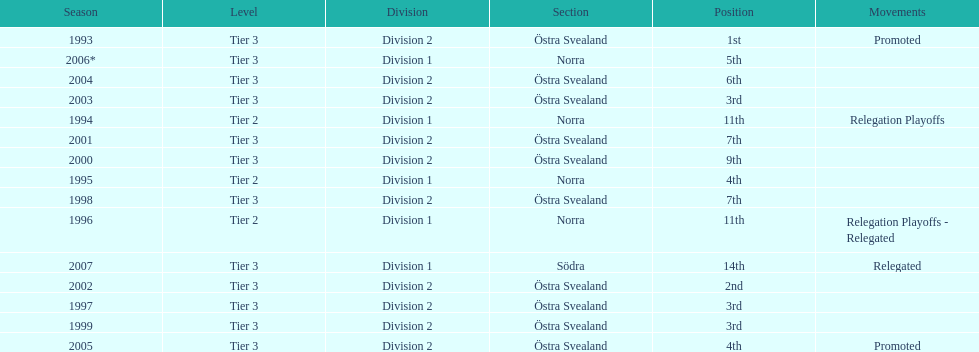What is the count of division 2 being listed as the division? 10. 